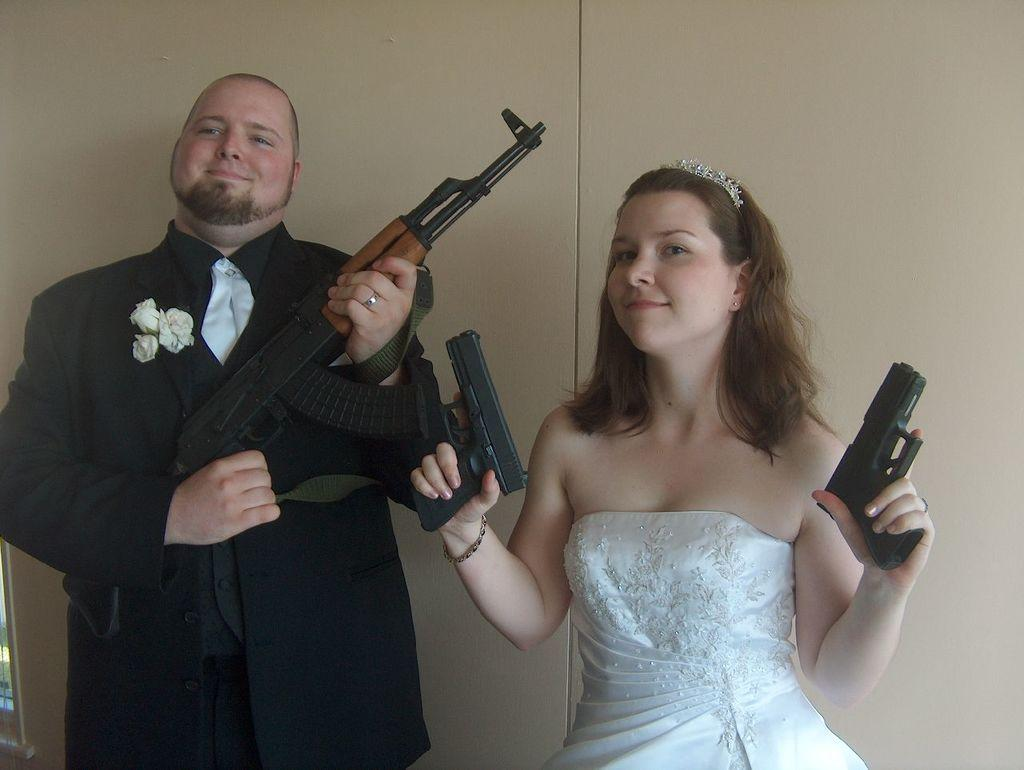What is the man on the right side of the image wearing? The man is wearing a black suit with roses. What is the man holding in the image? The man is holding a gun. Can you describe the lady in the image? The lady is also holding a gun. What can be seen in the background of the image? There is a wall in the background of the image. What type of glove is the man wearing in the image? There is no glove mentioned or visible in the image; the man is wearing a black suit with roses. How does the lady react to the man's presence in the image? The image does not show any reaction from the lady; it only shows her holding a gun. 